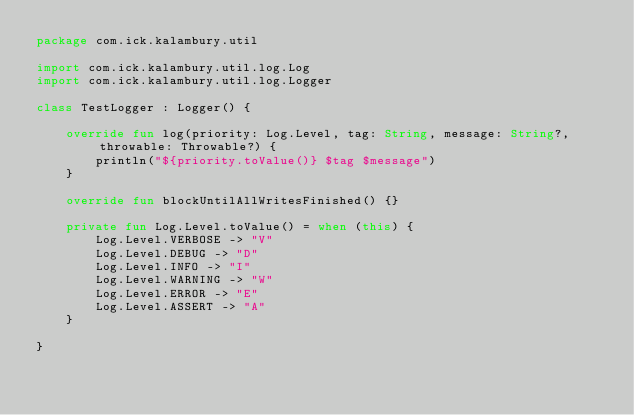<code> <loc_0><loc_0><loc_500><loc_500><_Kotlin_>package com.ick.kalambury.util

import com.ick.kalambury.util.log.Log
import com.ick.kalambury.util.log.Logger

class TestLogger : Logger() {

    override fun log(priority: Log.Level, tag: String, message: String?, throwable: Throwable?) {
        println("${priority.toValue()} $tag $message")
    }

    override fun blockUntilAllWritesFinished() {}

    private fun Log.Level.toValue() = when (this) {
        Log.Level.VERBOSE -> "V"
        Log.Level.DEBUG -> "D"
        Log.Level.INFO -> "I"
        Log.Level.WARNING -> "W"
        Log.Level.ERROR -> "E"
        Log.Level.ASSERT -> "A"
    }

}</code> 